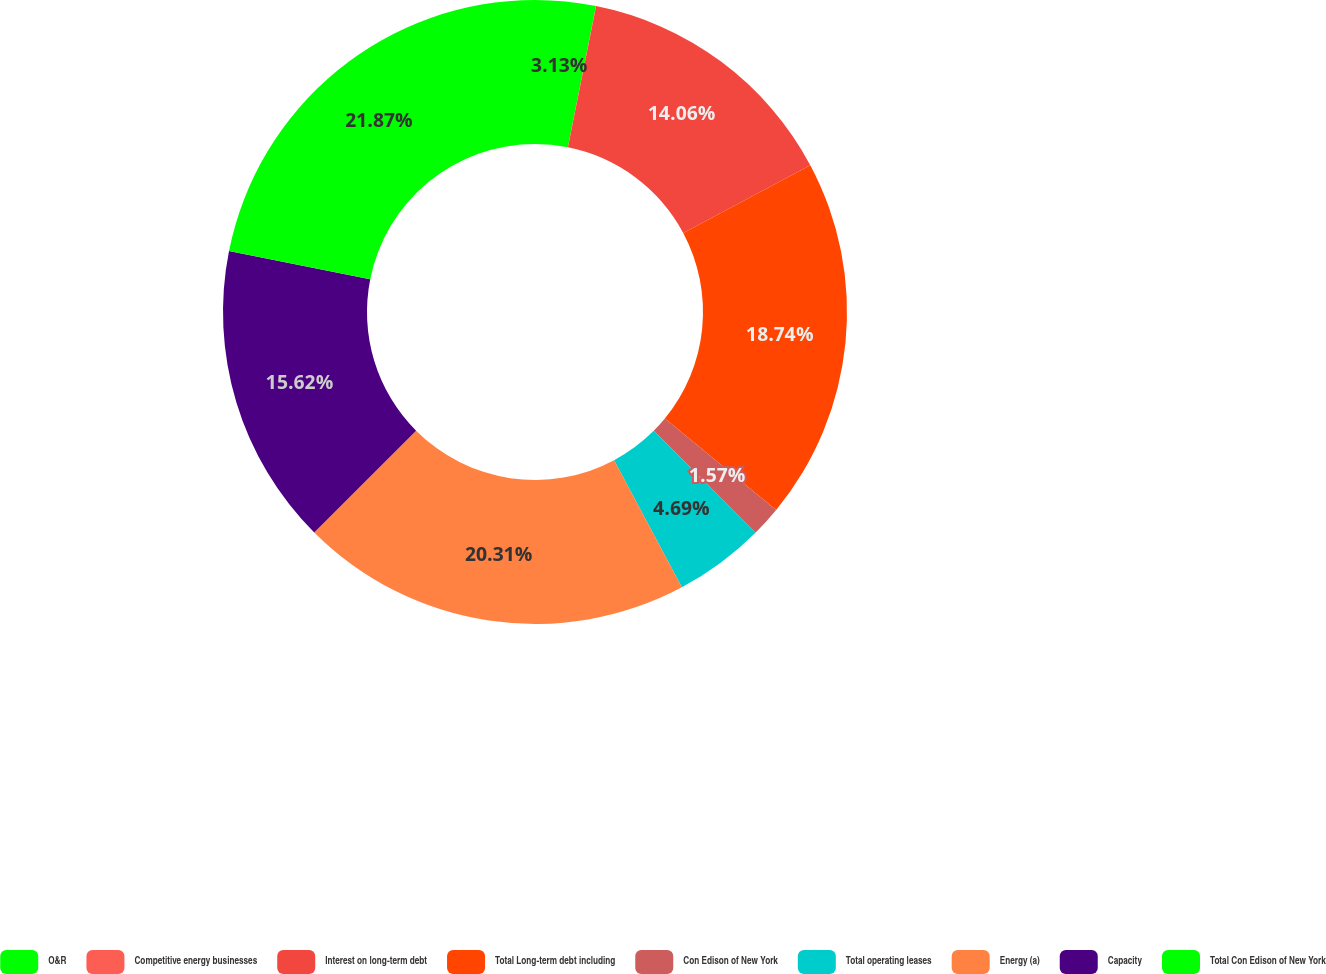<chart> <loc_0><loc_0><loc_500><loc_500><pie_chart><fcel>O&R<fcel>Competitive energy businesses<fcel>Interest on long-term debt<fcel>Total Long-term debt including<fcel>Con Edison of New York<fcel>Total operating leases<fcel>Energy (a)<fcel>Capacity<fcel>Total Con Edison of New York<nl><fcel>3.13%<fcel>0.01%<fcel>14.06%<fcel>18.74%<fcel>1.57%<fcel>4.69%<fcel>20.31%<fcel>15.62%<fcel>21.87%<nl></chart> 